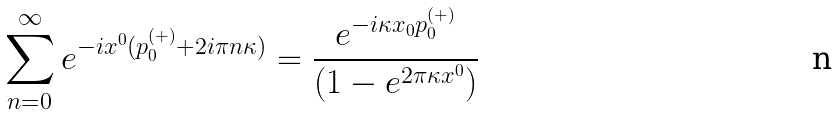<formula> <loc_0><loc_0><loc_500><loc_500>\sum _ { n = 0 } ^ { \infty } e ^ { - i x ^ { 0 } ( p _ { 0 } ^ { ( + ) } + 2 i \pi n \kappa ) } = \frac { e ^ { - i \kappa x _ { 0 } p _ { 0 } ^ { ( + ) } } } { ( 1 - e ^ { 2 \pi \kappa x ^ { 0 } } ) }</formula> 